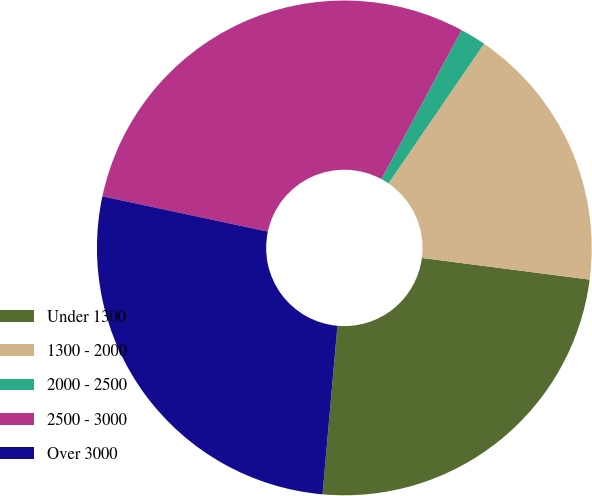Convert chart. <chart><loc_0><loc_0><loc_500><loc_500><pie_chart><fcel>Under 1300<fcel>1300 - 2000<fcel>2000 - 2500<fcel>2500 - 3000<fcel>Over 3000<nl><fcel>24.36%<fcel>17.49%<fcel>1.69%<fcel>29.52%<fcel>26.94%<nl></chart> 